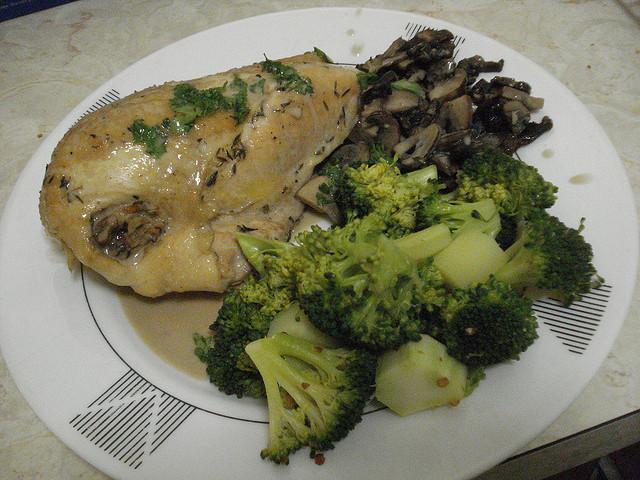Could that protein have been roasted?
Answer briefly. Yes. What are the two white items in this image?
Keep it brief. Plate and chicken. What is this green vegetable?
Short answer required. Broccoli. Is there a hamburger on the plate?
Write a very short answer. No. Where is the plate placed?
Quick response, please. Counter. What is the design on the plate?
Answer briefly. Round. What vegetables are on the plate?
Keep it brief. Broccoli. Is the plate completely white?
Short answer required. No. What spice is on the chicken?
Short answer required. Basil. 